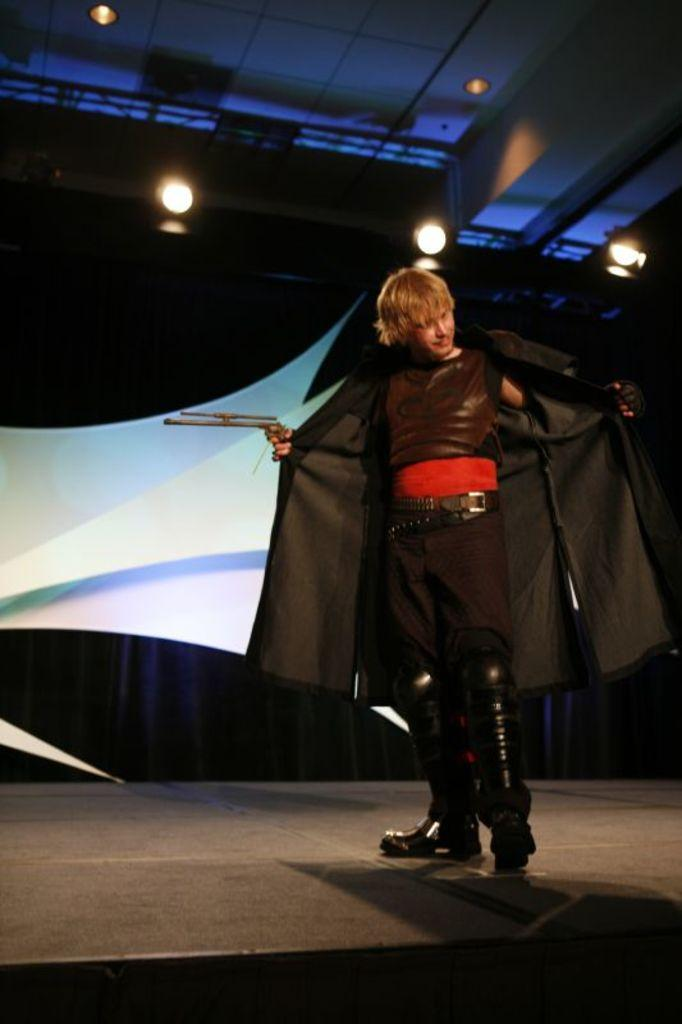What is hanging in the image? There is a banner in the image. What can be seen illuminating the scene in the image? There are lights in the image. Who is present in the image wearing a specific type of clothing? There is a man wearing a black dress in the image. Can you tell me how many tigers are depicted on the banner in the image? There are no tigers depicted on the banner in the image. What type of berry is being used as a decoration on the man's black dress? There is no mention of berries or any decorations on the man's black dress in the image. 